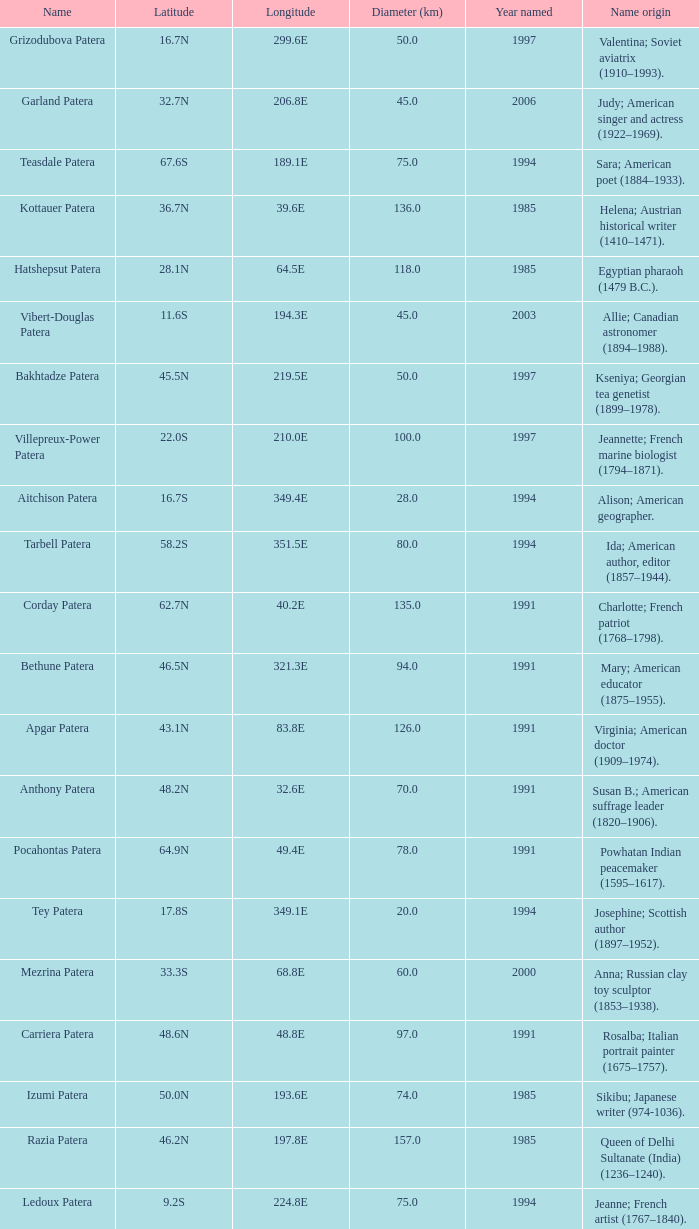What is the diameter in km of the feature named Colette Patera?  149.0. 